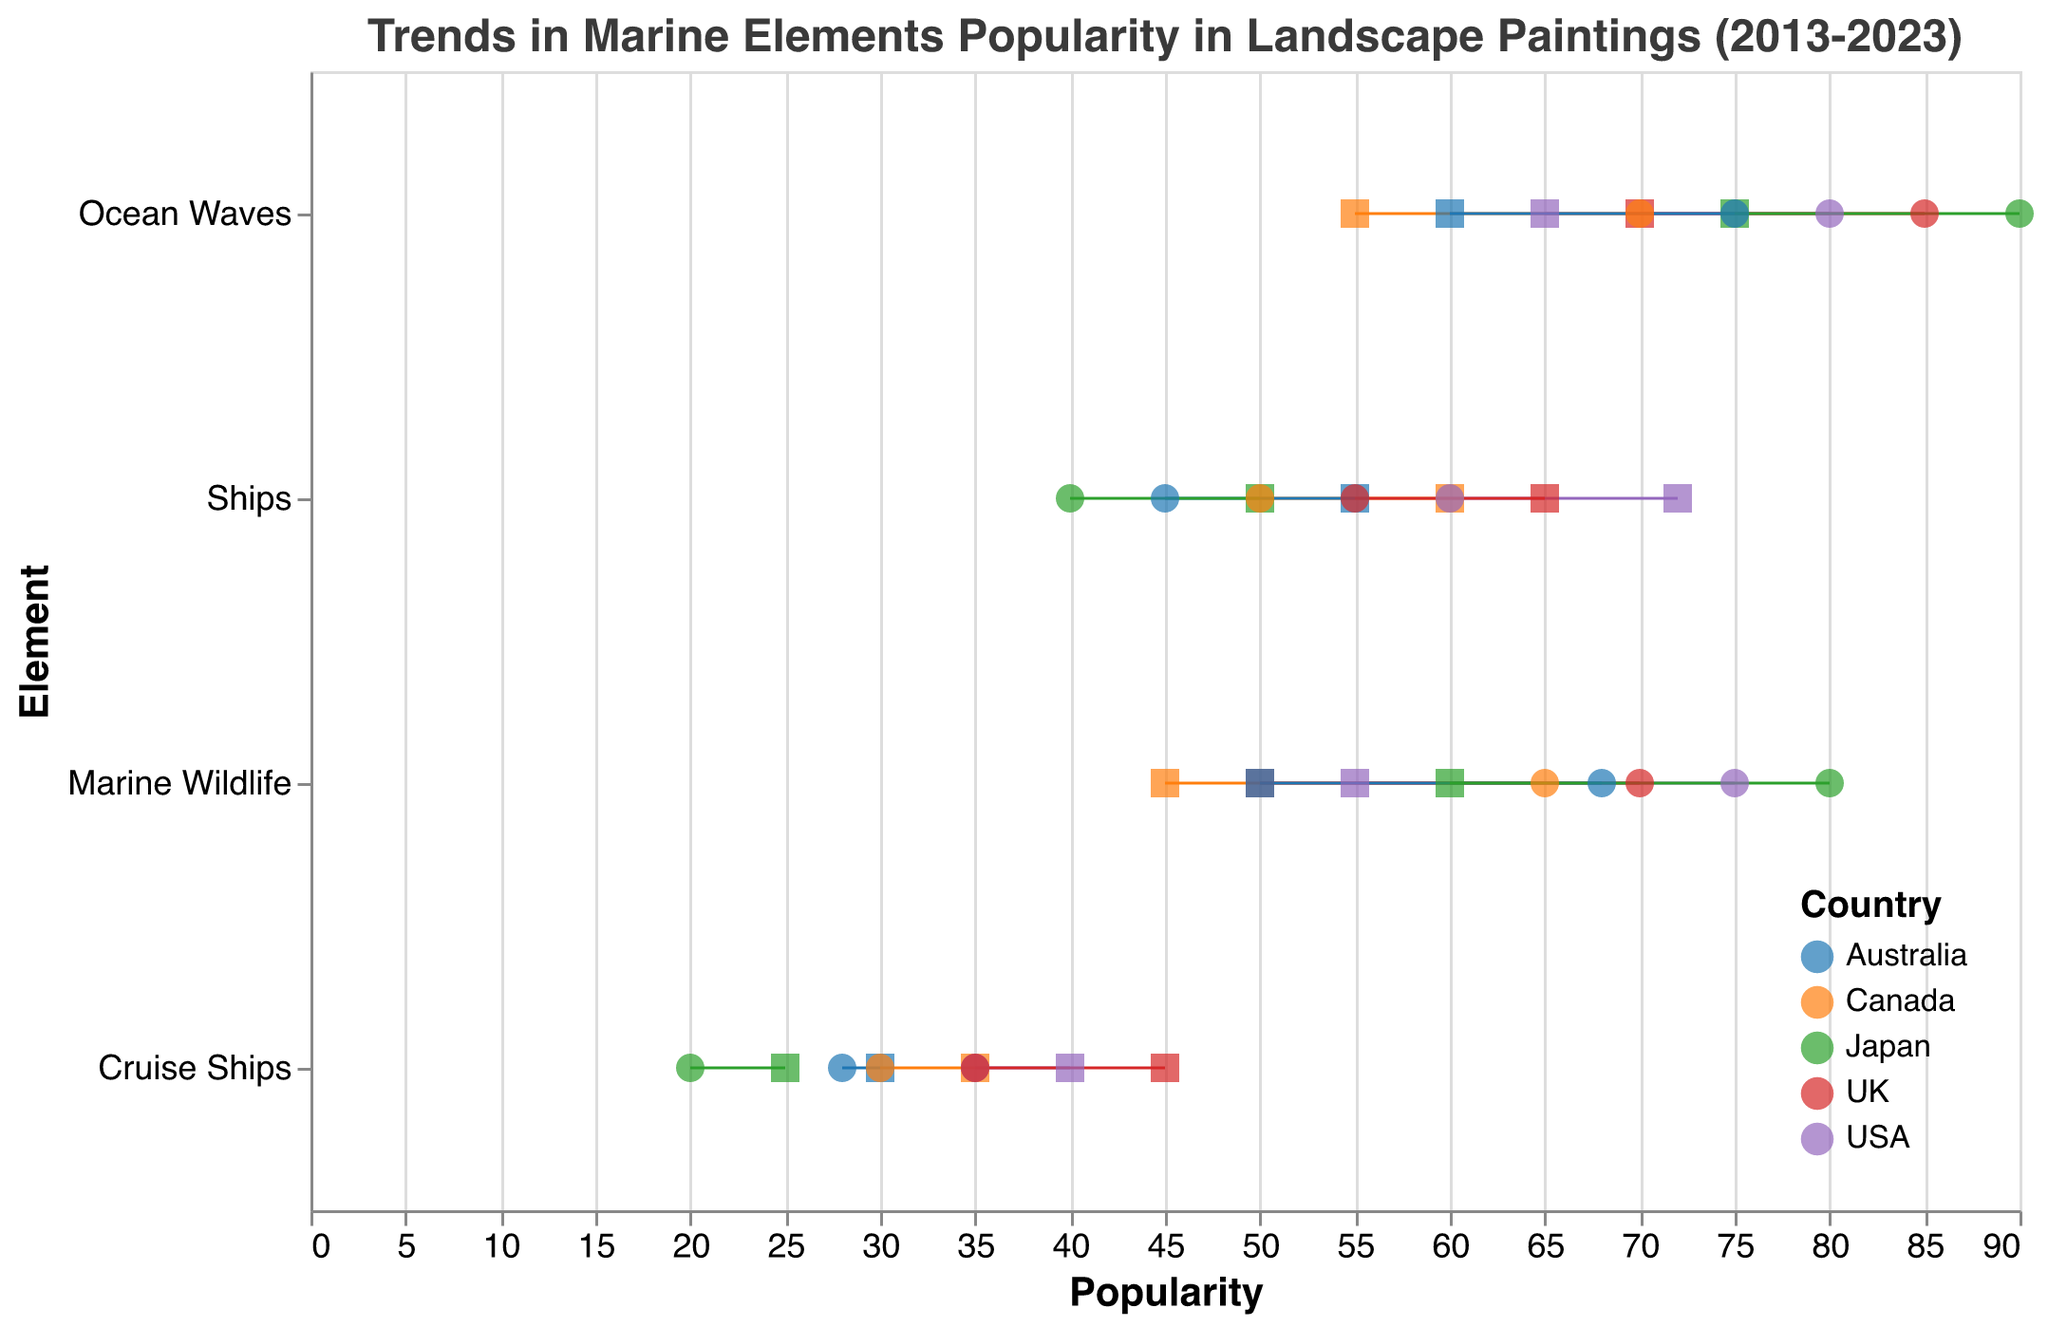what is the title of the plot? The title is displayed at the top of the plot.
Answer: Trends in Marine Elements Popularity in Landscape Paintings (2013-2023) Which marine element showed the largest increase in popularity in the UK? By examining the overall shift from 2013 to 2023, Marine Wildlife in the UK shows the largest increase.
Answer: Marine Wildlife How did the popularity of Ocean Waves in Japan change from 2013 to 2023? Look at the x-position of the points for Japan in 2013 and 2023 for Ocean Waves. Ocean Waves' popularity increased from 75 to 90.
Answer: Increased Which country saw a decrease in the popularity of Cruise Ships the most from 2013 to 2023? By comparing the popularity values of Cruise Ships across all countries, USA saw the most significant decrease from 40 to 35.
Answer: USA Which country had the highest popularity for Marine Wildlife in 2023? Check the 2023 point for Marine Wildlife across all countries. Japan has the highest popularity with a score of 80 in 2023.
Answer: Japan What is the difference in popularity of Ships between 2013 and 2023 in Canada? Subtract the 2023 popularity from the 2013 popularity for Ships in Canada: 60 - 50 = 10.
Answer: 10 Compare the change in popularity of Ocean Waves between USA and Canada. Which one had a larger increase? Calculate the change for both countries: USA (80 - 65 = 15) and Canada (70 - 55 = 15), and observe that both had the same increase.
Answer: Same increase Which country had a decrease in popularity for all marine elements from 2013 to 2023? By examining each element's trend for each country, only Japan had a decrease for Ships and Cruise Ships while others had increases or stable trends.
Answer: None What was the popularity of Ocean Waves in the USA in 2013? Check the x-value point corresponding to Ocean Waves for the USA in 2013.
Answer: 65 Between the UK and Australia, which country had a larger increase in popularity for Marine Wildlife? Calculate the changes: UK (70 - 50 = 20) and Australia (68 - 50 = 18), and compare them.
Answer: UK 